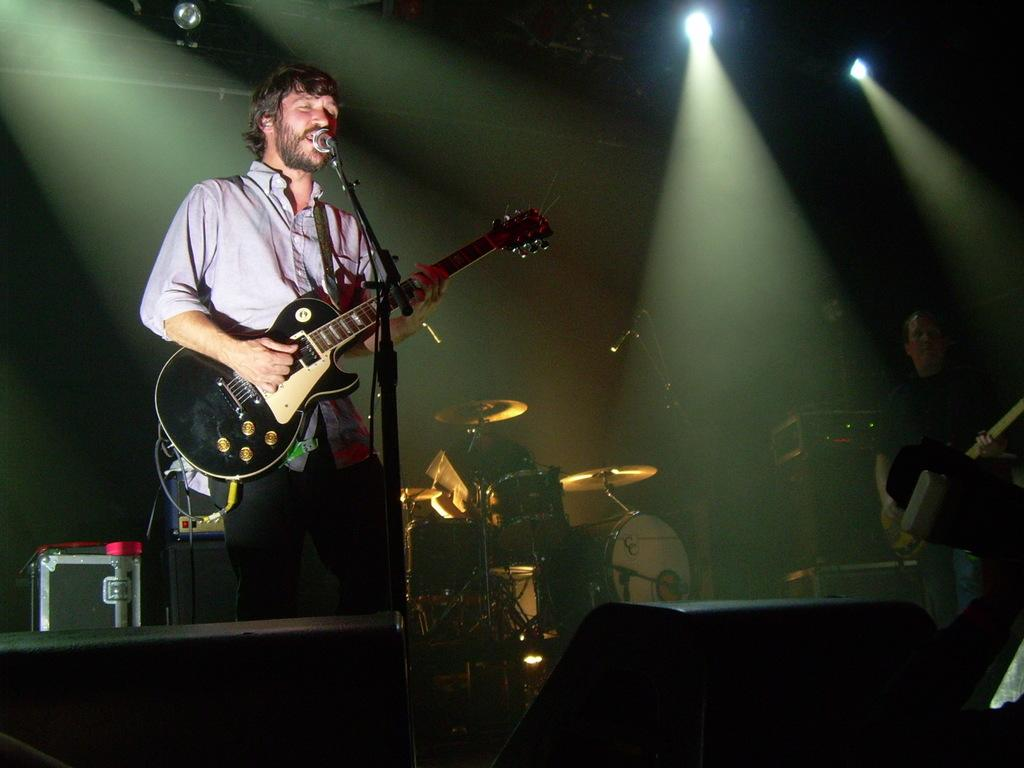What is the person in the image holding? The person is holding a guitar in the image. What is the person standing near in the image? The person is standing in front of a microphone. What can be seen in the background of the image? There are musical instruments in the background of the image. Are there any other people visible in the image? Yes, there is at least one other person in the background of the image. What type of chicken can be seen perched on the shelf in the image? There is no chicken or shelf present in the image. Can you describe the owl's expression as it watches the person playing the guitar? There is no owl present in the image. 